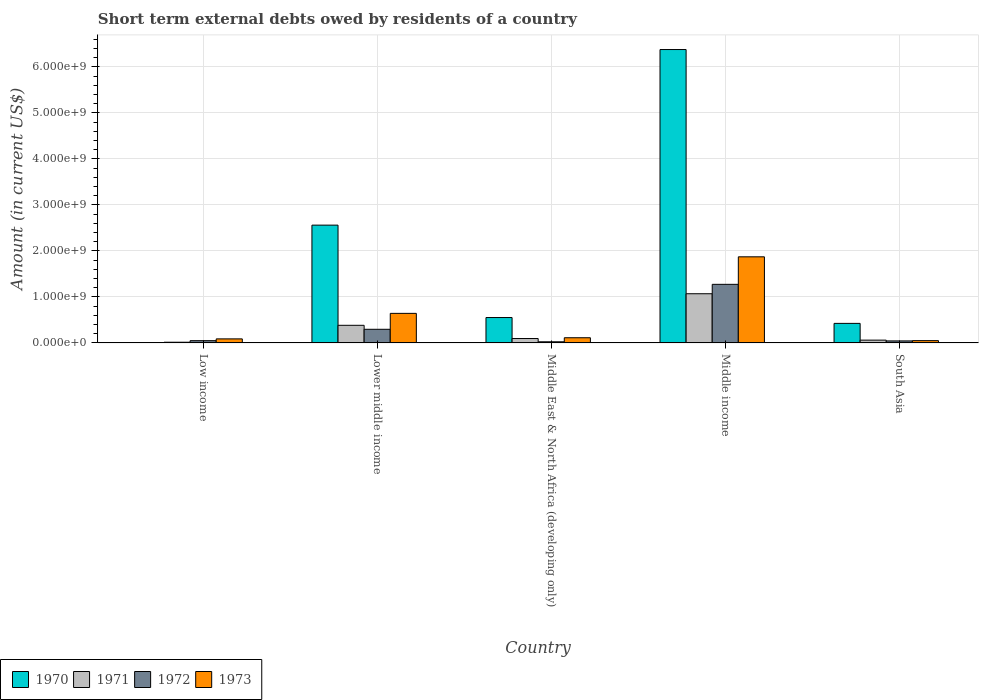How many different coloured bars are there?
Provide a succinct answer. 4. How many groups of bars are there?
Offer a terse response. 5. Are the number of bars per tick equal to the number of legend labels?
Keep it short and to the point. No. How many bars are there on the 3rd tick from the right?
Give a very brief answer. 4. What is the label of the 3rd group of bars from the left?
Keep it short and to the point. Middle East & North Africa (developing only). In how many cases, is the number of bars for a given country not equal to the number of legend labels?
Offer a very short reply. 1. Across all countries, what is the maximum amount of short-term external debts owed by residents in 1973?
Provide a succinct answer. 1.87e+09. What is the total amount of short-term external debts owed by residents in 1972 in the graph?
Make the answer very short. 1.69e+09. What is the difference between the amount of short-term external debts owed by residents in 1973 in Middle East & North Africa (developing only) and that in Middle income?
Keep it short and to the point. -1.76e+09. What is the difference between the amount of short-term external debts owed by residents in 1972 in Low income and the amount of short-term external debts owed by residents in 1971 in Middle East & North Africa (developing only)?
Your response must be concise. -4.66e+07. What is the average amount of short-term external debts owed by residents in 1971 per country?
Keep it short and to the point. 3.25e+08. What is the difference between the amount of short-term external debts owed by residents of/in 1972 and amount of short-term external debts owed by residents of/in 1973 in Lower middle income?
Provide a short and direct response. -3.46e+08. In how many countries, is the amount of short-term external debts owed by residents in 1972 greater than 5800000000 US$?
Your answer should be compact. 0. What is the ratio of the amount of short-term external debts owed by residents in 1973 in Middle East & North Africa (developing only) to that in South Asia?
Provide a short and direct response. 2.26. Is the amount of short-term external debts owed by residents in 1971 in Middle East & North Africa (developing only) less than that in South Asia?
Provide a succinct answer. No. Is the difference between the amount of short-term external debts owed by residents in 1972 in Middle East & North Africa (developing only) and South Asia greater than the difference between the amount of short-term external debts owed by residents in 1973 in Middle East & North Africa (developing only) and South Asia?
Your response must be concise. No. What is the difference between the highest and the second highest amount of short-term external debts owed by residents in 1970?
Provide a succinct answer. 5.83e+09. What is the difference between the highest and the lowest amount of short-term external debts owed by residents in 1971?
Offer a terse response. 1.05e+09. In how many countries, is the amount of short-term external debts owed by residents in 1973 greater than the average amount of short-term external debts owed by residents in 1973 taken over all countries?
Provide a succinct answer. 2. Is the sum of the amount of short-term external debts owed by residents in 1970 in Lower middle income and Middle East & North Africa (developing only) greater than the maximum amount of short-term external debts owed by residents in 1971 across all countries?
Ensure brevity in your answer.  Yes. How many bars are there?
Keep it short and to the point. 19. Are all the bars in the graph horizontal?
Offer a very short reply. No. How many countries are there in the graph?
Offer a very short reply. 5. What is the difference between two consecutive major ticks on the Y-axis?
Ensure brevity in your answer.  1.00e+09. What is the title of the graph?
Your response must be concise. Short term external debts owed by residents of a country. What is the label or title of the Y-axis?
Give a very brief answer. Amount (in current US$). What is the Amount (in current US$) in 1970 in Low income?
Offer a very short reply. 0. What is the Amount (in current US$) of 1971 in Low income?
Make the answer very short. 1.54e+07. What is the Amount (in current US$) of 1972 in Low income?
Offer a terse response. 4.94e+07. What is the Amount (in current US$) in 1973 in Low income?
Your answer should be very brief. 8.84e+07. What is the Amount (in current US$) in 1970 in Lower middle income?
Give a very brief answer. 2.56e+09. What is the Amount (in current US$) of 1971 in Lower middle income?
Ensure brevity in your answer.  3.83e+08. What is the Amount (in current US$) of 1972 in Lower middle income?
Keep it short and to the point. 2.97e+08. What is the Amount (in current US$) of 1973 in Lower middle income?
Your answer should be compact. 6.43e+08. What is the Amount (in current US$) in 1970 in Middle East & North Africa (developing only)?
Give a very brief answer. 5.52e+08. What is the Amount (in current US$) of 1971 in Middle East & North Africa (developing only)?
Provide a short and direct response. 9.60e+07. What is the Amount (in current US$) in 1972 in Middle East & North Africa (developing only)?
Offer a terse response. 2.50e+07. What is the Amount (in current US$) in 1973 in Middle East & North Africa (developing only)?
Ensure brevity in your answer.  1.13e+08. What is the Amount (in current US$) in 1970 in Middle income?
Ensure brevity in your answer.  6.38e+09. What is the Amount (in current US$) of 1971 in Middle income?
Make the answer very short. 1.07e+09. What is the Amount (in current US$) in 1972 in Middle income?
Offer a very short reply. 1.27e+09. What is the Amount (in current US$) in 1973 in Middle income?
Provide a short and direct response. 1.87e+09. What is the Amount (in current US$) in 1970 in South Asia?
Offer a very short reply. 4.25e+08. What is the Amount (in current US$) in 1971 in South Asia?
Your answer should be very brief. 6.10e+07. What is the Amount (in current US$) of 1972 in South Asia?
Make the answer very short. 4.40e+07. What is the Amount (in current US$) of 1973 in South Asia?
Your answer should be compact. 5.00e+07. Across all countries, what is the maximum Amount (in current US$) of 1970?
Provide a succinct answer. 6.38e+09. Across all countries, what is the maximum Amount (in current US$) in 1971?
Your answer should be compact. 1.07e+09. Across all countries, what is the maximum Amount (in current US$) of 1972?
Your answer should be very brief. 1.27e+09. Across all countries, what is the maximum Amount (in current US$) of 1973?
Give a very brief answer. 1.87e+09. Across all countries, what is the minimum Amount (in current US$) in 1971?
Ensure brevity in your answer.  1.54e+07. Across all countries, what is the minimum Amount (in current US$) in 1972?
Your answer should be compact. 2.50e+07. What is the total Amount (in current US$) in 1970 in the graph?
Provide a succinct answer. 9.92e+09. What is the total Amount (in current US$) in 1971 in the graph?
Your answer should be very brief. 1.63e+09. What is the total Amount (in current US$) in 1972 in the graph?
Provide a short and direct response. 1.69e+09. What is the total Amount (in current US$) of 1973 in the graph?
Provide a short and direct response. 2.77e+09. What is the difference between the Amount (in current US$) of 1971 in Low income and that in Lower middle income?
Provide a succinct answer. -3.68e+08. What is the difference between the Amount (in current US$) of 1972 in Low income and that in Lower middle income?
Offer a terse response. -2.47e+08. What is the difference between the Amount (in current US$) of 1973 in Low income and that in Lower middle income?
Your response must be concise. -5.54e+08. What is the difference between the Amount (in current US$) in 1971 in Low income and that in Middle East & North Africa (developing only)?
Your response must be concise. -8.06e+07. What is the difference between the Amount (in current US$) in 1972 in Low income and that in Middle East & North Africa (developing only)?
Offer a very short reply. 2.44e+07. What is the difference between the Amount (in current US$) in 1973 in Low income and that in Middle East & North Africa (developing only)?
Make the answer very short. -2.46e+07. What is the difference between the Amount (in current US$) in 1971 in Low income and that in Middle income?
Provide a short and direct response. -1.05e+09. What is the difference between the Amount (in current US$) of 1972 in Low income and that in Middle income?
Ensure brevity in your answer.  -1.22e+09. What is the difference between the Amount (in current US$) of 1973 in Low income and that in Middle income?
Provide a succinct answer. -1.78e+09. What is the difference between the Amount (in current US$) of 1971 in Low income and that in South Asia?
Ensure brevity in your answer.  -4.56e+07. What is the difference between the Amount (in current US$) in 1972 in Low income and that in South Asia?
Make the answer very short. 5.35e+06. What is the difference between the Amount (in current US$) of 1973 in Low income and that in South Asia?
Keep it short and to the point. 3.84e+07. What is the difference between the Amount (in current US$) in 1970 in Lower middle income and that in Middle East & North Africa (developing only)?
Make the answer very short. 2.01e+09. What is the difference between the Amount (in current US$) in 1971 in Lower middle income and that in Middle East & North Africa (developing only)?
Provide a succinct answer. 2.87e+08. What is the difference between the Amount (in current US$) in 1972 in Lower middle income and that in Middle East & North Africa (developing only)?
Keep it short and to the point. 2.72e+08. What is the difference between the Amount (in current US$) in 1973 in Lower middle income and that in Middle East & North Africa (developing only)?
Ensure brevity in your answer.  5.30e+08. What is the difference between the Amount (in current US$) in 1970 in Lower middle income and that in Middle income?
Your response must be concise. -3.82e+09. What is the difference between the Amount (in current US$) of 1971 in Lower middle income and that in Middle income?
Your answer should be very brief. -6.86e+08. What is the difference between the Amount (in current US$) of 1972 in Lower middle income and that in Middle income?
Offer a terse response. -9.77e+08. What is the difference between the Amount (in current US$) in 1973 in Lower middle income and that in Middle income?
Offer a very short reply. -1.23e+09. What is the difference between the Amount (in current US$) in 1970 in Lower middle income and that in South Asia?
Offer a terse response. 2.14e+09. What is the difference between the Amount (in current US$) of 1971 in Lower middle income and that in South Asia?
Offer a terse response. 3.22e+08. What is the difference between the Amount (in current US$) in 1972 in Lower middle income and that in South Asia?
Your answer should be very brief. 2.53e+08. What is the difference between the Amount (in current US$) of 1973 in Lower middle income and that in South Asia?
Your answer should be compact. 5.93e+08. What is the difference between the Amount (in current US$) in 1970 in Middle East & North Africa (developing only) and that in Middle income?
Offer a very short reply. -5.83e+09. What is the difference between the Amount (in current US$) in 1971 in Middle East & North Africa (developing only) and that in Middle income?
Make the answer very short. -9.73e+08. What is the difference between the Amount (in current US$) in 1972 in Middle East & North Africa (developing only) and that in Middle income?
Make the answer very short. -1.25e+09. What is the difference between the Amount (in current US$) of 1973 in Middle East & North Africa (developing only) and that in Middle income?
Give a very brief answer. -1.76e+09. What is the difference between the Amount (in current US$) in 1970 in Middle East & North Africa (developing only) and that in South Asia?
Offer a very short reply. 1.27e+08. What is the difference between the Amount (in current US$) in 1971 in Middle East & North Africa (developing only) and that in South Asia?
Keep it short and to the point. 3.50e+07. What is the difference between the Amount (in current US$) of 1972 in Middle East & North Africa (developing only) and that in South Asia?
Keep it short and to the point. -1.90e+07. What is the difference between the Amount (in current US$) in 1973 in Middle East & North Africa (developing only) and that in South Asia?
Provide a short and direct response. 6.30e+07. What is the difference between the Amount (in current US$) in 1970 in Middle income and that in South Asia?
Keep it short and to the point. 5.95e+09. What is the difference between the Amount (in current US$) of 1971 in Middle income and that in South Asia?
Give a very brief answer. 1.01e+09. What is the difference between the Amount (in current US$) of 1972 in Middle income and that in South Asia?
Offer a terse response. 1.23e+09. What is the difference between the Amount (in current US$) in 1973 in Middle income and that in South Asia?
Provide a succinct answer. 1.82e+09. What is the difference between the Amount (in current US$) in 1971 in Low income and the Amount (in current US$) in 1972 in Lower middle income?
Make the answer very short. -2.81e+08. What is the difference between the Amount (in current US$) of 1971 in Low income and the Amount (in current US$) of 1973 in Lower middle income?
Make the answer very short. -6.27e+08. What is the difference between the Amount (in current US$) in 1972 in Low income and the Amount (in current US$) in 1973 in Lower middle income?
Your answer should be very brief. -5.93e+08. What is the difference between the Amount (in current US$) of 1971 in Low income and the Amount (in current US$) of 1972 in Middle East & North Africa (developing only)?
Provide a succinct answer. -9.65e+06. What is the difference between the Amount (in current US$) in 1971 in Low income and the Amount (in current US$) in 1973 in Middle East & North Africa (developing only)?
Offer a very short reply. -9.76e+07. What is the difference between the Amount (in current US$) in 1972 in Low income and the Amount (in current US$) in 1973 in Middle East & North Africa (developing only)?
Offer a very short reply. -6.36e+07. What is the difference between the Amount (in current US$) of 1971 in Low income and the Amount (in current US$) of 1972 in Middle income?
Make the answer very short. -1.26e+09. What is the difference between the Amount (in current US$) of 1971 in Low income and the Amount (in current US$) of 1973 in Middle income?
Give a very brief answer. -1.86e+09. What is the difference between the Amount (in current US$) of 1972 in Low income and the Amount (in current US$) of 1973 in Middle income?
Your answer should be very brief. -1.82e+09. What is the difference between the Amount (in current US$) in 1971 in Low income and the Amount (in current US$) in 1972 in South Asia?
Make the answer very short. -2.86e+07. What is the difference between the Amount (in current US$) in 1971 in Low income and the Amount (in current US$) in 1973 in South Asia?
Your answer should be very brief. -3.46e+07. What is the difference between the Amount (in current US$) in 1972 in Low income and the Amount (in current US$) in 1973 in South Asia?
Keep it short and to the point. -6.46e+05. What is the difference between the Amount (in current US$) in 1970 in Lower middle income and the Amount (in current US$) in 1971 in Middle East & North Africa (developing only)?
Keep it short and to the point. 2.46e+09. What is the difference between the Amount (in current US$) in 1970 in Lower middle income and the Amount (in current US$) in 1972 in Middle East & North Africa (developing only)?
Keep it short and to the point. 2.54e+09. What is the difference between the Amount (in current US$) of 1970 in Lower middle income and the Amount (in current US$) of 1973 in Middle East & North Africa (developing only)?
Provide a succinct answer. 2.45e+09. What is the difference between the Amount (in current US$) of 1971 in Lower middle income and the Amount (in current US$) of 1972 in Middle East & North Africa (developing only)?
Ensure brevity in your answer.  3.58e+08. What is the difference between the Amount (in current US$) in 1971 in Lower middle income and the Amount (in current US$) in 1973 in Middle East & North Africa (developing only)?
Your response must be concise. 2.70e+08. What is the difference between the Amount (in current US$) of 1972 in Lower middle income and the Amount (in current US$) of 1973 in Middle East & North Africa (developing only)?
Ensure brevity in your answer.  1.84e+08. What is the difference between the Amount (in current US$) of 1970 in Lower middle income and the Amount (in current US$) of 1971 in Middle income?
Offer a very short reply. 1.49e+09. What is the difference between the Amount (in current US$) in 1970 in Lower middle income and the Amount (in current US$) in 1972 in Middle income?
Make the answer very short. 1.29e+09. What is the difference between the Amount (in current US$) of 1970 in Lower middle income and the Amount (in current US$) of 1973 in Middle income?
Provide a short and direct response. 6.89e+08. What is the difference between the Amount (in current US$) of 1971 in Lower middle income and the Amount (in current US$) of 1972 in Middle income?
Ensure brevity in your answer.  -8.91e+08. What is the difference between the Amount (in current US$) of 1971 in Lower middle income and the Amount (in current US$) of 1973 in Middle income?
Ensure brevity in your answer.  -1.49e+09. What is the difference between the Amount (in current US$) in 1972 in Lower middle income and the Amount (in current US$) in 1973 in Middle income?
Keep it short and to the point. -1.58e+09. What is the difference between the Amount (in current US$) in 1970 in Lower middle income and the Amount (in current US$) in 1971 in South Asia?
Offer a very short reply. 2.50e+09. What is the difference between the Amount (in current US$) in 1970 in Lower middle income and the Amount (in current US$) in 1972 in South Asia?
Provide a short and direct response. 2.52e+09. What is the difference between the Amount (in current US$) in 1970 in Lower middle income and the Amount (in current US$) in 1973 in South Asia?
Your answer should be compact. 2.51e+09. What is the difference between the Amount (in current US$) in 1971 in Lower middle income and the Amount (in current US$) in 1972 in South Asia?
Ensure brevity in your answer.  3.39e+08. What is the difference between the Amount (in current US$) in 1971 in Lower middle income and the Amount (in current US$) in 1973 in South Asia?
Ensure brevity in your answer.  3.33e+08. What is the difference between the Amount (in current US$) of 1972 in Lower middle income and the Amount (in current US$) of 1973 in South Asia?
Your response must be concise. 2.47e+08. What is the difference between the Amount (in current US$) in 1970 in Middle East & North Africa (developing only) and the Amount (in current US$) in 1971 in Middle income?
Your response must be concise. -5.17e+08. What is the difference between the Amount (in current US$) of 1970 in Middle East & North Africa (developing only) and the Amount (in current US$) of 1972 in Middle income?
Give a very brief answer. -7.22e+08. What is the difference between the Amount (in current US$) of 1970 in Middle East & North Africa (developing only) and the Amount (in current US$) of 1973 in Middle income?
Your answer should be very brief. -1.32e+09. What is the difference between the Amount (in current US$) of 1971 in Middle East & North Africa (developing only) and the Amount (in current US$) of 1972 in Middle income?
Provide a succinct answer. -1.18e+09. What is the difference between the Amount (in current US$) of 1971 in Middle East & North Africa (developing only) and the Amount (in current US$) of 1973 in Middle income?
Keep it short and to the point. -1.78e+09. What is the difference between the Amount (in current US$) of 1972 in Middle East & North Africa (developing only) and the Amount (in current US$) of 1973 in Middle income?
Your response must be concise. -1.85e+09. What is the difference between the Amount (in current US$) of 1970 in Middle East & North Africa (developing only) and the Amount (in current US$) of 1971 in South Asia?
Your answer should be very brief. 4.91e+08. What is the difference between the Amount (in current US$) of 1970 in Middle East & North Africa (developing only) and the Amount (in current US$) of 1972 in South Asia?
Keep it short and to the point. 5.08e+08. What is the difference between the Amount (in current US$) of 1970 in Middle East & North Africa (developing only) and the Amount (in current US$) of 1973 in South Asia?
Your answer should be very brief. 5.02e+08. What is the difference between the Amount (in current US$) of 1971 in Middle East & North Africa (developing only) and the Amount (in current US$) of 1972 in South Asia?
Offer a terse response. 5.20e+07. What is the difference between the Amount (in current US$) of 1971 in Middle East & North Africa (developing only) and the Amount (in current US$) of 1973 in South Asia?
Give a very brief answer. 4.60e+07. What is the difference between the Amount (in current US$) of 1972 in Middle East & North Africa (developing only) and the Amount (in current US$) of 1973 in South Asia?
Provide a succinct answer. -2.50e+07. What is the difference between the Amount (in current US$) of 1970 in Middle income and the Amount (in current US$) of 1971 in South Asia?
Your response must be concise. 6.32e+09. What is the difference between the Amount (in current US$) of 1970 in Middle income and the Amount (in current US$) of 1972 in South Asia?
Your response must be concise. 6.33e+09. What is the difference between the Amount (in current US$) in 1970 in Middle income and the Amount (in current US$) in 1973 in South Asia?
Offer a terse response. 6.33e+09. What is the difference between the Amount (in current US$) in 1971 in Middle income and the Amount (in current US$) in 1972 in South Asia?
Your answer should be very brief. 1.03e+09. What is the difference between the Amount (in current US$) of 1971 in Middle income and the Amount (in current US$) of 1973 in South Asia?
Your response must be concise. 1.02e+09. What is the difference between the Amount (in current US$) in 1972 in Middle income and the Amount (in current US$) in 1973 in South Asia?
Make the answer very short. 1.22e+09. What is the average Amount (in current US$) in 1970 per country?
Your response must be concise. 1.98e+09. What is the average Amount (in current US$) in 1971 per country?
Keep it short and to the point. 3.25e+08. What is the average Amount (in current US$) of 1972 per country?
Your response must be concise. 3.38e+08. What is the average Amount (in current US$) of 1973 per country?
Offer a terse response. 5.53e+08. What is the difference between the Amount (in current US$) in 1971 and Amount (in current US$) in 1972 in Low income?
Offer a terse response. -3.40e+07. What is the difference between the Amount (in current US$) in 1971 and Amount (in current US$) in 1973 in Low income?
Provide a short and direct response. -7.30e+07. What is the difference between the Amount (in current US$) of 1972 and Amount (in current US$) of 1973 in Low income?
Provide a short and direct response. -3.90e+07. What is the difference between the Amount (in current US$) of 1970 and Amount (in current US$) of 1971 in Lower middle income?
Your answer should be compact. 2.18e+09. What is the difference between the Amount (in current US$) of 1970 and Amount (in current US$) of 1972 in Lower middle income?
Make the answer very short. 2.26e+09. What is the difference between the Amount (in current US$) in 1970 and Amount (in current US$) in 1973 in Lower middle income?
Your answer should be very brief. 1.92e+09. What is the difference between the Amount (in current US$) in 1971 and Amount (in current US$) in 1972 in Lower middle income?
Offer a terse response. 8.65e+07. What is the difference between the Amount (in current US$) of 1971 and Amount (in current US$) of 1973 in Lower middle income?
Your answer should be compact. -2.60e+08. What is the difference between the Amount (in current US$) of 1972 and Amount (in current US$) of 1973 in Lower middle income?
Your answer should be compact. -3.46e+08. What is the difference between the Amount (in current US$) in 1970 and Amount (in current US$) in 1971 in Middle East & North Africa (developing only)?
Offer a terse response. 4.56e+08. What is the difference between the Amount (in current US$) of 1970 and Amount (in current US$) of 1972 in Middle East & North Africa (developing only)?
Offer a terse response. 5.27e+08. What is the difference between the Amount (in current US$) in 1970 and Amount (in current US$) in 1973 in Middle East & North Africa (developing only)?
Provide a short and direct response. 4.39e+08. What is the difference between the Amount (in current US$) of 1971 and Amount (in current US$) of 1972 in Middle East & North Africa (developing only)?
Provide a succinct answer. 7.10e+07. What is the difference between the Amount (in current US$) in 1971 and Amount (in current US$) in 1973 in Middle East & North Africa (developing only)?
Provide a short and direct response. -1.70e+07. What is the difference between the Amount (in current US$) in 1972 and Amount (in current US$) in 1973 in Middle East & North Africa (developing only)?
Your response must be concise. -8.80e+07. What is the difference between the Amount (in current US$) of 1970 and Amount (in current US$) of 1971 in Middle income?
Your answer should be compact. 5.31e+09. What is the difference between the Amount (in current US$) of 1970 and Amount (in current US$) of 1972 in Middle income?
Ensure brevity in your answer.  5.10e+09. What is the difference between the Amount (in current US$) in 1970 and Amount (in current US$) in 1973 in Middle income?
Offer a very short reply. 4.51e+09. What is the difference between the Amount (in current US$) in 1971 and Amount (in current US$) in 1972 in Middle income?
Offer a very short reply. -2.05e+08. What is the difference between the Amount (in current US$) of 1971 and Amount (in current US$) of 1973 in Middle income?
Your response must be concise. -8.03e+08. What is the difference between the Amount (in current US$) in 1972 and Amount (in current US$) in 1973 in Middle income?
Your response must be concise. -5.98e+08. What is the difference between the Amount (in current US$) in 1970 and Amount (in current US$) in 1971 in South Asia?
Offer a terse response. 3.64e+08. What is the difference between the Amount (in current US$) in 1970 and Amount (in current US$) in 1972 in South Asia?
Offer a very short reply. 3.81e+08. What is the difference between the Amount (in current US$) in 1970 and Amount (in current US$) in 1973 in South Asia?
Keep it short and to the point. 3.75e+08. What is the difference between the Amount (in current US$) in 1971 and Amount (in current US$) in 1972 in South Asia?
Offer a terse response. 1.70e+07. What is the difference between the Amount (in current US$) in 1971 and Amount (in current US$) in 1973 in South Asia?
Make the answer very short. 1.10e+07. What is the difference between the Amount (in current US$) of 1972 and Amount (in current US$) of 1973 in South Asia?
Offer a very short reply. -6.00e+06. What is the ratio of the Amount (in current US$) of 1971 in Low income to that in Lower middle income?
Give a very brief answer. 0.04. What is the ratio of the Amount (in current US$) in 1972 in Low income to that in Lower middle income?
Your response must be concise. 0.17. What is the ratio of the Amount (in current US$) in 1973 in Low income to that in Lower middle income?
Offer a terse response. 0.14. What is the ratio of the Amount (in current US$) of 1971 in Low income to that in Middle East & North Africa (developing only)?
Your response must be concise. 0.16. What is the ratio of the Amount (in current US$) in 1972 in Low income to that in Middle East & North Africa (developing only)?
Provide a succinct answer. 1.97. What is the ratio of the Amount (in current US$) in 1973 in Low income to that in Middle East & North Africa (developing only)?
Your answer should be compact. 0.78. What is the ratio of the Amount (in current US$) in 1971 in Low income to that in Middle income?
Provide a short and direct response. 0.01. What is the ratio of the Amount (in current US$) in 1972 in Low income to that in Middle income?
Offer a terse response. 0.04. What is the ratio of the Amount (in current US$) in 1973 in Low income to that in Middle income?
Your answer should be very brief. 0.05. What is the ratio of the Amount (in current US$) of 1971 in Low income to that in South Asia?
Your answer should be very brief. 0.25. What is the ratio of the Amount (in current US$) of 1972 in Low income to that in South Asia?
Provide a short and direct response. 1.12. What is the ratio of the Amount (in current US$) in 1973 in Low income to that in South Asia?
Make the answer very short. 1.77. What is the ratio of the Amount (in current US$) in 1970 in Lower middle income to that in Middle East & North Africa (developing only)?
Provide a short and direct response. 4.64. What is the ratio of the Amount (in current US$) of 1971 in Lower middle income to that in Middle East & North Africa (developing only)?
Give a very brief answer. 3.99. What is the ratio of the Amount (in current US$) in 1972 in Lower middle income to that in Middle East & North Africa (developing only)?
Offer a terse response. 11.87. What is the ratio of the Amount (in current US$) in 1973 in Lower middle income to that in Middle East & North Africa (developing only)?
Provide a succinct answer. 5.69. What is the ratio of the Amount (in current US$) of 1970 in Lower middle income to that in Middle income?
Offer a terse response. 0.4. What is the ratio of the Amount (in current US$) of 1971 in Lower middle income to that in Middle income?
Offer a terse response. 0.36. What is the ratio of the Amount (in current US$) in 1972 in Lower middle income to that in Middle income?
Make the answer very short. 0.23. What is the ratio of the Amount (in current US$) of 1973 in Lower middle income to that in Middle income?
Offer a terse response. 0.34. What is the ratio of the Amount (in current US$) of 1970 in Lower middle income to that in South Asia?
Your response must be concise. 6.03. What is the ratio of the Amount (in current US$) in 1971 in Lower middle income to that in South Asia?
Ensure brevity in your answer.  6.28. What is the ratio of the Amount (in current US$) of 1972 in Lower middle income to that in South Asia?
Your answer should be compact. 6.75. What is the ratio of the Amount (in current US$) of 1973 in Lower middle income to that in South Asia?
Provide a short and direct response. 12.86. What is the ratio of the Amount (in current US$) in 1970 in Middle East & North Africa (developing only) to that in Middle income?
Ensure brevity in your answer.  0.09. What is the ratio of the Amount (in current US$) in 1971 in Middle East & North Africa (developing only) to that in Middle income?
Keep it short and to the point. 0.09. What is the ratio of the Amount (in current US$) in 1972 in Middle East & North Africa (developing only) to that in Middle income?
Your response must be concise. 0.02. What is the ratio of the Amount (in current US$) in 1973 in Middle East & North Africa (developing only) to that in Middle income?
Keep it short and to the point. 0.06. What is the ratio of the Amount (in current US$) of 1970 in Middle East & North Africa (developing only) to that in South Asia?
Your answer should be compact. 1.3. What is the ratio of the Amount (in current US$) of 1971 in Middle East & North Africa (developing only) to that in South Asia?
Give a very brief answer. 1.57. What is the ratio of the Amount (in current US$) of 1972 in Middle East & North Africa (developing only) to that in South Asia?
Ensure brevity in your answer.  0.57. What is the ratio of the Amount (in current US$) in 1973 in Middle East & North Africa (developing only) to that in South Asia?
Provide a short and direct response. 2.26. What is the ratio of the Amount (in current US$) of 1970 in Middle income to that in South Asia?
Ensure brevity in your answer.  15.01. What is the ratio of the Amount (in current US$) of 1971 in Middle income to that in South Asia?
Offer a terse response. 17.53. What is the ratio of the Amount (in current US$) of 1972 in Middle income to that in South Asia?
Offer a terse response. 28.95. What is the ratio of the Amount (in current US$) in 1973 in Middle income to that in South Asia?
Provide a succinct answer. 37.44. What is the difference between the highest and the second highest Amount (in current US$) in 1970?
Ensure brevity in your answer.  3.82e+09. What is the difference between the highest and the second highest Amount (in current US$) in 1971?
Offer a terse response. 6.86e+08. What is the difference between the highest and the second highest Amount (in current US$) of 1972?
Make the answer very short. 9.77e+08. What is the difference between the highest and the second highest Amount (in current US$) of 1973?
Provide a succinct answer. 1.23e+09. What is the difference between the highest and the lowest Amount (in current US$) in 1970?
Keep it short and to the point. 6.38e+09. What is the difference between the highest and the lowest Amount (in current US$) of 1971?
Make the answer very short. 1.05e+09. What is the difference between the highest and the lowest Amount (in current US$) in 1972?
Provide a succinct answer. 1.25e+09. What is the difference between the highest and the lowest Amount (in current US$) in 1973?
Provide a succinct answer. 1.82e+09. 